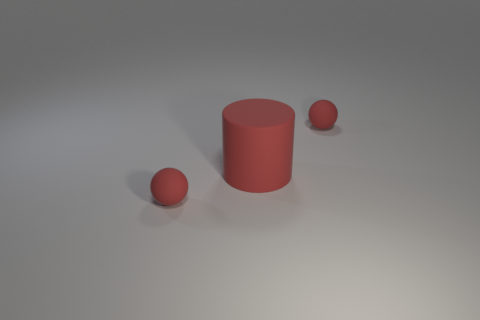Do the cylinder and the red sphere that is to the left of the big red cylinder have the same size?
Make the answer very short. No. There is a small red object on the right side of the large rubber cylinder; how many red spheres are in front of it?
Your answer should be compact. 1. What is the color of the tiny rubber ball that is right of the tiny rubber thing that is in front of the big red cylinder?
Make the answer very short. Red. Are there more red balls than brown metal spheres?
Keep it short and to the point. Yes. How many red things have the same size as the red cylinder?
Provide a short and direct response. 0. Are the big red thing and the red object that is on the right side of the large red rubber thing made of the same material?
Ensure brevity in your answer.  Yes. Is the number of red matte spheres less than the number of large cyan shiny cylinders?
Offer a very short reply. No. There is a red matte ball behind the small red rubber object in front of the big red thing; what number of big matte things are in front of it?
Your response must be concise. 1. Is the number of red matte cylinders behind the large rubber cylinder less than the number of large red rubber cylinders?
Keep it short and to the point. Yes. How many tiny things are rubber objects or blue shiny objects?
Provide a short and direct response. 2. 